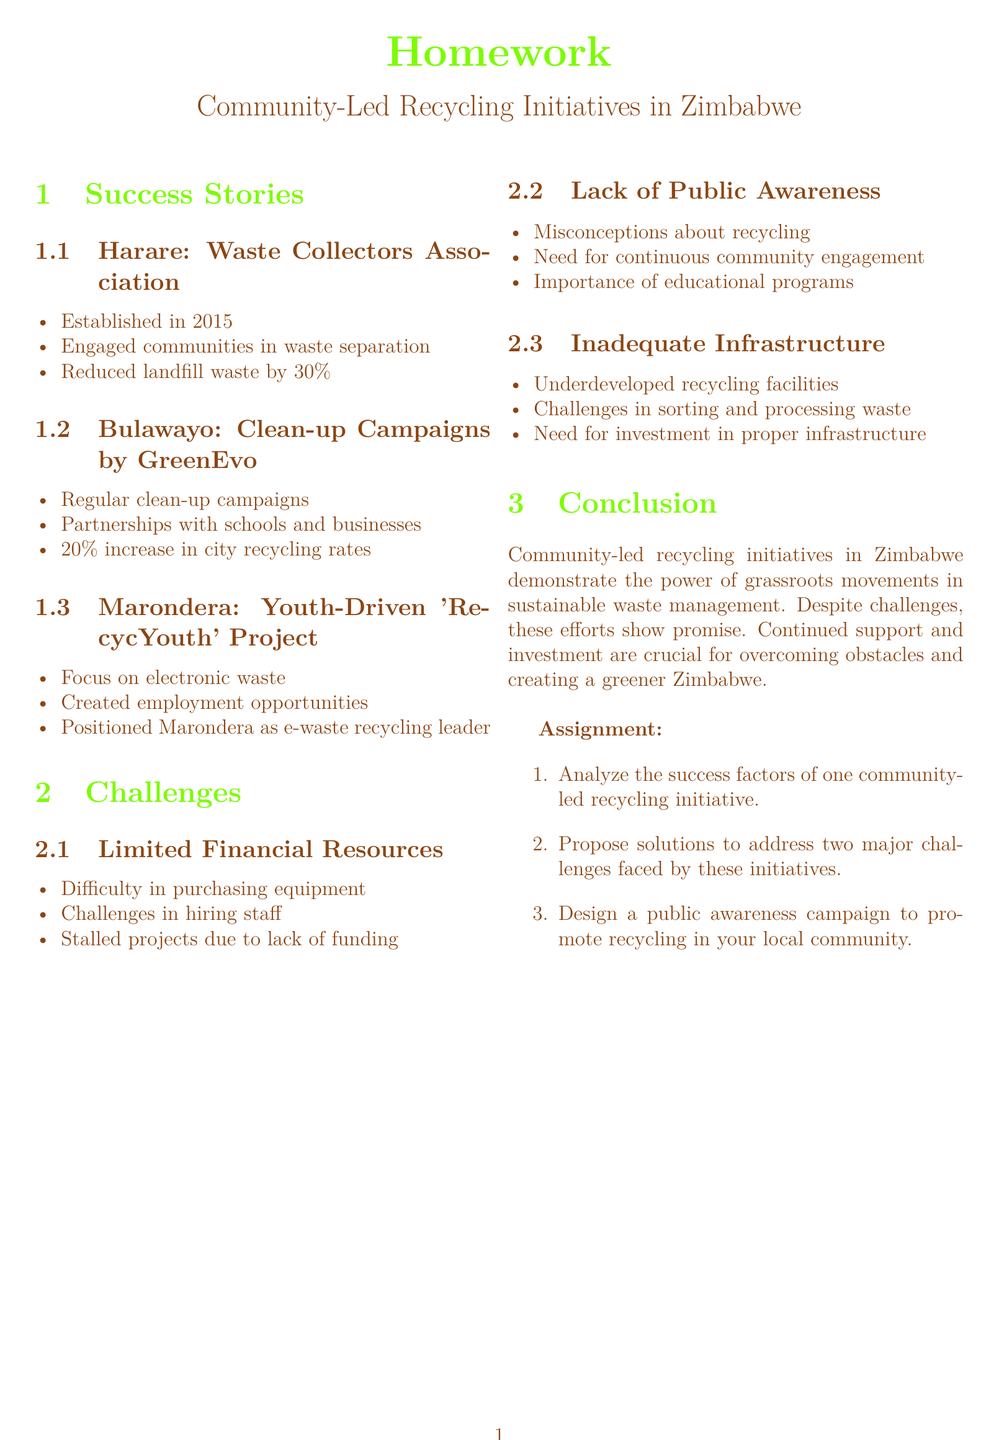What year was the Waste Collectors Association established? The document states that the Waste Collectors Association was established in 2015.
Answer: 2015 How much has landfill waste been reduced by the Waste Collectors Association? The document mentions a 30% reduction in landfill waste due to the initiative's efforts.
Answer: 30% Which city is the e-waste recycling leader according to the RecycYouth project? The document indicates that Marondera is positioned as the e-waste recycling leader.
Answer: Marondera What is one challenge faced by community-led recycling initiatives? The document lists several challenges, one of which is limited financial resources.
Answer: Limited Financial Resources What percentage increase in recycling rates did GreenEvo achieve in Bulawayo? The document states that GreenEvo achieved a 20% increase in city recycling rates.
Answer: 20% Name one focus area of the Youth-Driven 'RecycYouth' Project. According to the document, the RecycYouth project focuses on electronic waste.
Answer: Electronic waste What is the importance of educational programs as mentioned in the document? The document discusses that educational programs are important to address public misconceptions about recycling.
Answer: Importance of educational programs What should be designed to promote recycling in local communities according to the assignment? The assignment suggests designing a public awareness campaign to promote recycling.
Answer: Public awareness campaign 